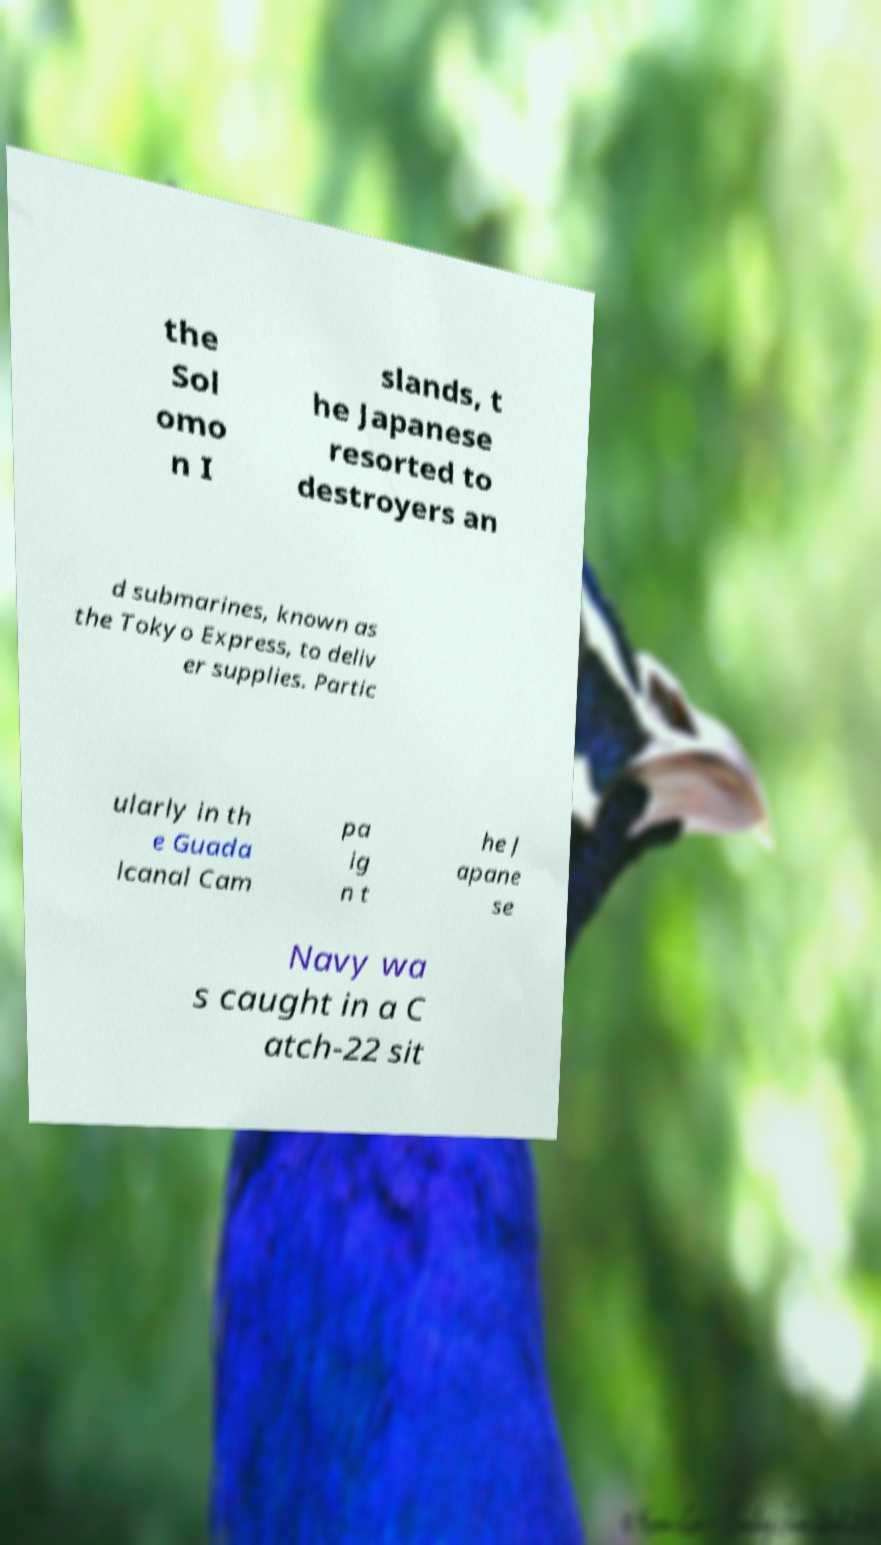Can you accurately transcribe the text from the provided image for me? the Sol omo n I slands, t he Japanese resorted to destroyers an d submarines, known as the Tokyo Express, to deliv er supplies. Partic ularly in th e Guada lcanal Cam pa ig n t he J apane se Navy wa s caught in a C atch-22 sit 